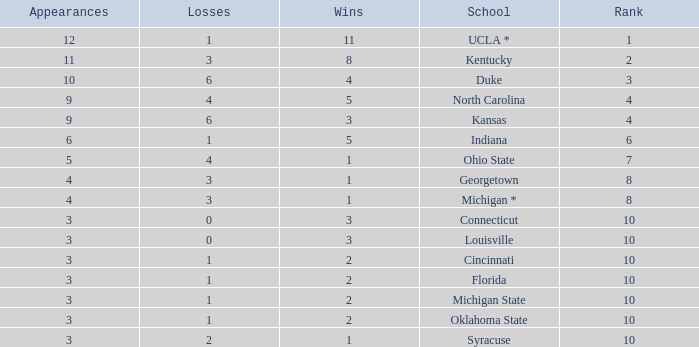Tell me the sum of losses for wins less than 2 and rank of 10 with appearances larger than 3 None. 